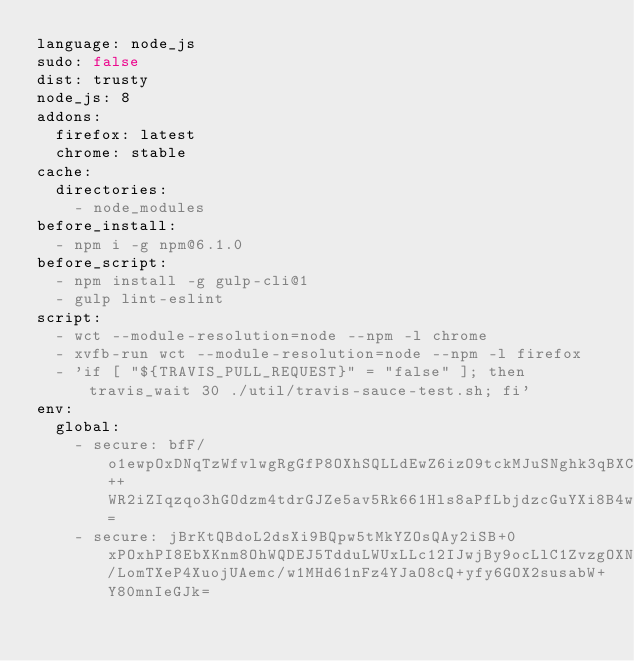<code> <loc_0><loc_0><loc_500><loc_500><_YAML_>language: node_js
sudo: false
dist: trusty
node_js: 8
addons:
  firefox: latest
  chrome: stable
cache:
  directories:
    - node_modules
before_install:
  - npm i -g npm@6.1.0
before_script:
  - npm install -g gulp-cli@1
  - gulp lint-eslint
script:
  - wct --module-resolution=node --npm -l chrome
  - xvfb-run wct --module-resolution=node --npm -l firefox
  - 'if [ "${TRAVIS_PULL_REQUEST}" = "false" ]; then travis_wait 30 ./util/travis-sauce-test.sh; fi'
env:
  global:
    - secure: bfF/o1ewpOxDNqTzWfvlwgRgGfP8OXhSQLLdEwZ6izO9tckMJuSNghk3qBXCEQJwTcUEyXP6EqfzIrRAvDXPa0H3OoinbrooDyV2wIDaVRK++WR2iZIqzqo3hGOdzm4tdrGJZe5av5Rk661Hls8aPfLbjdzcGuYXi8B4wZq2xMI=
    - secure: jBrKtQBdoL2dsXi9BQpw5tMkYZOsQAy2iSB+0xPOxhPI8EbXKnm8OhWQDEJ5TdduLWUxLLc12IJwjBy9ocLlC1ZvzgOXNfqOUkLD03qSPnyT/LomTXeP4XuojUAemc/w1MHd61nFz4YJaO8cQ+yfy6GOX2susabW+Y80mnIeGJk=

</code> 